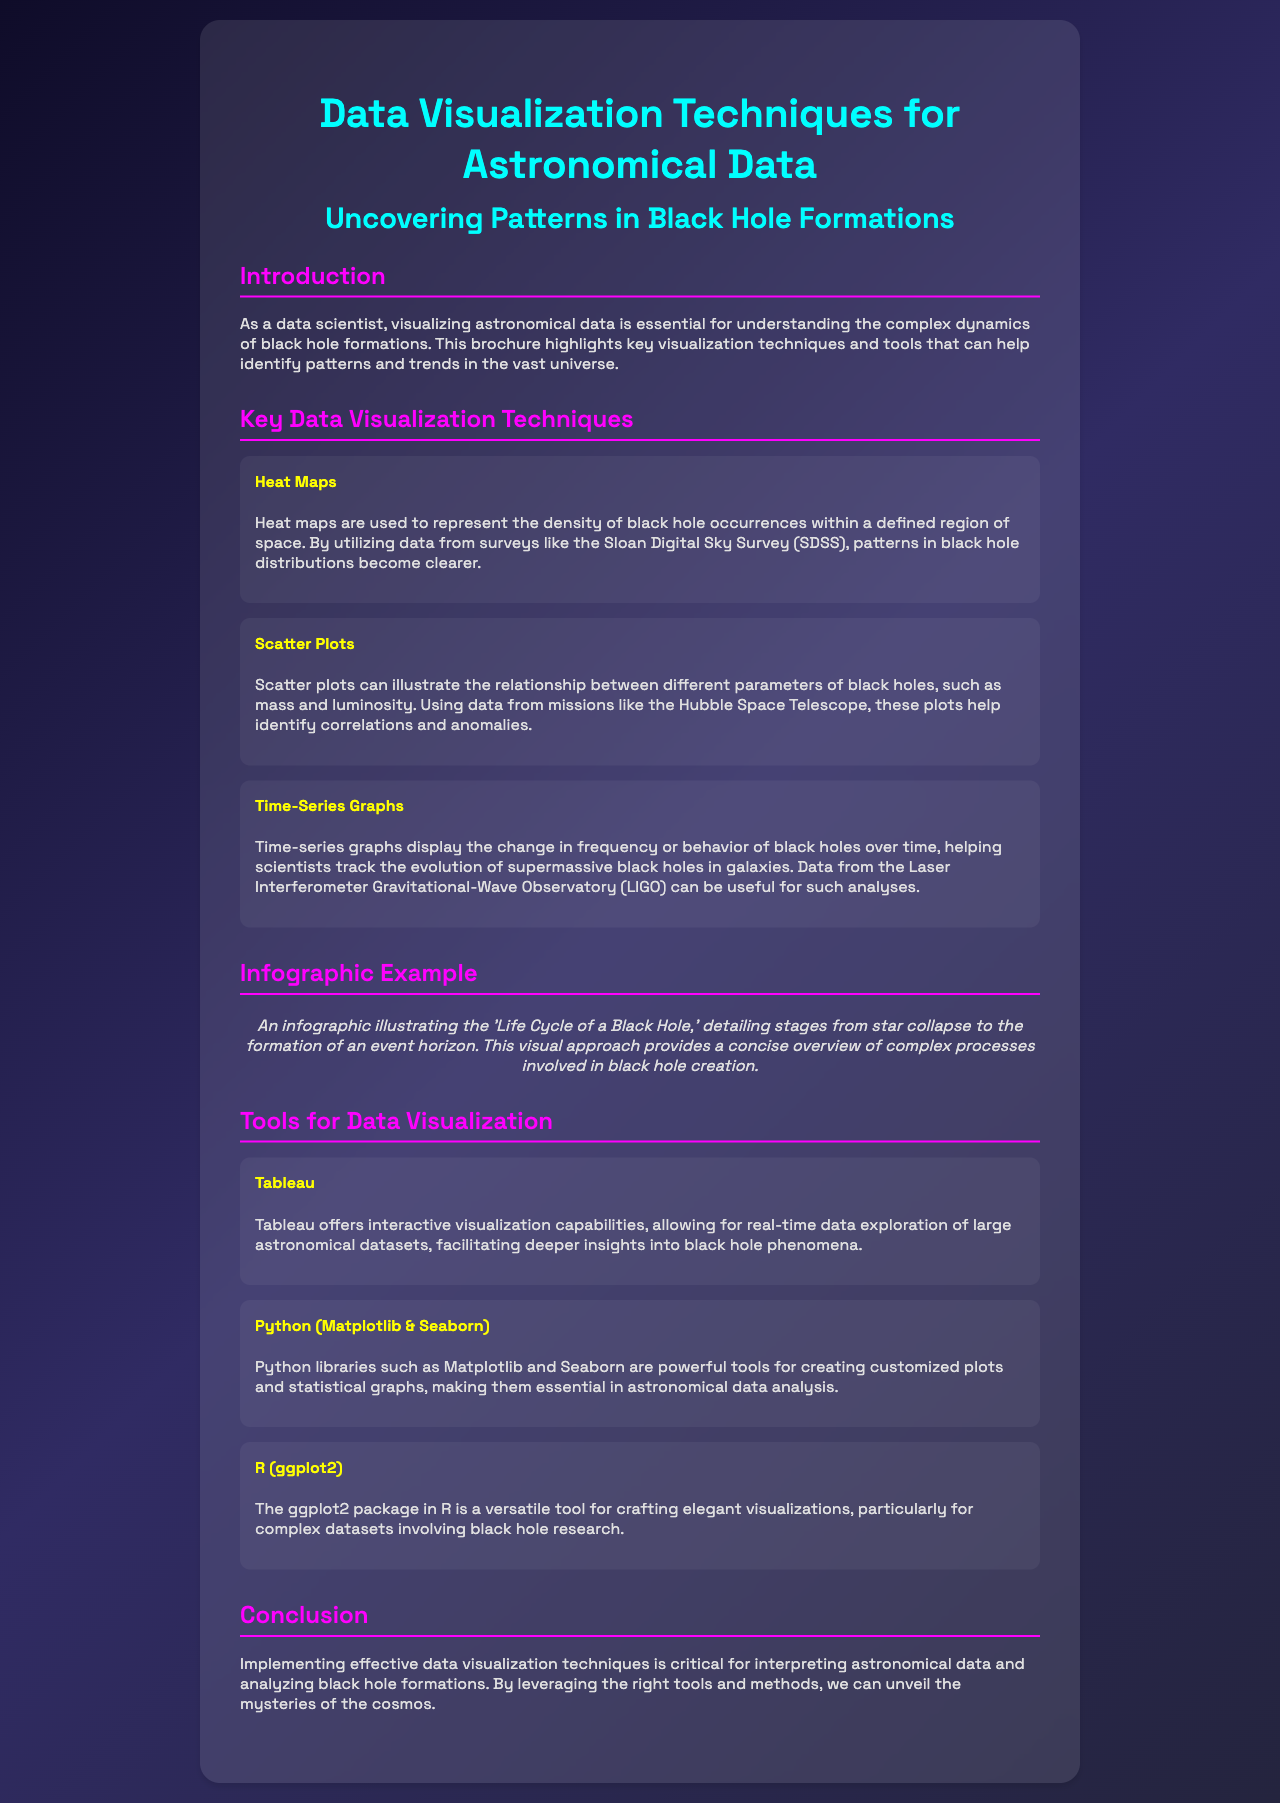What is the title of the brochure? The title of the brochure is presented prominently at the top of the document.
Answer: Data Visualization Techniques for Astronomical Data What is one type of data visualization technique mentioned? The brochure lists several visualization techniques; one is described in the key techniques section.
Answer: Heat Maps Which tool is used for creating statistical graphs in Python? The document specifies a Python library that is useful for data analysis and plotting.
Answer: Matplotlib What example is given in the infographic section? The infographic section describes a specific topic related to black holes.
Answer: Life Cycle of a Black Hole How many key data visualization techniques are listed? The brochure includes an enumerated list of techniques in a specific section.
Answer: Three What color is used for section headers in the brochure? The color used for section headers is specified in the document's design details.
Answer: Magenta What does the conclusion emphasize about data visualization? The conclusion summarizes the importance highlighted throughout the brochure.
Answer: Critical for interpreting astronomical data Which library is mentioned as a tool for elegant visualizations in R? The brochure identifies a specific package in R for visualization in the tools section.
Answer: ggplot2 